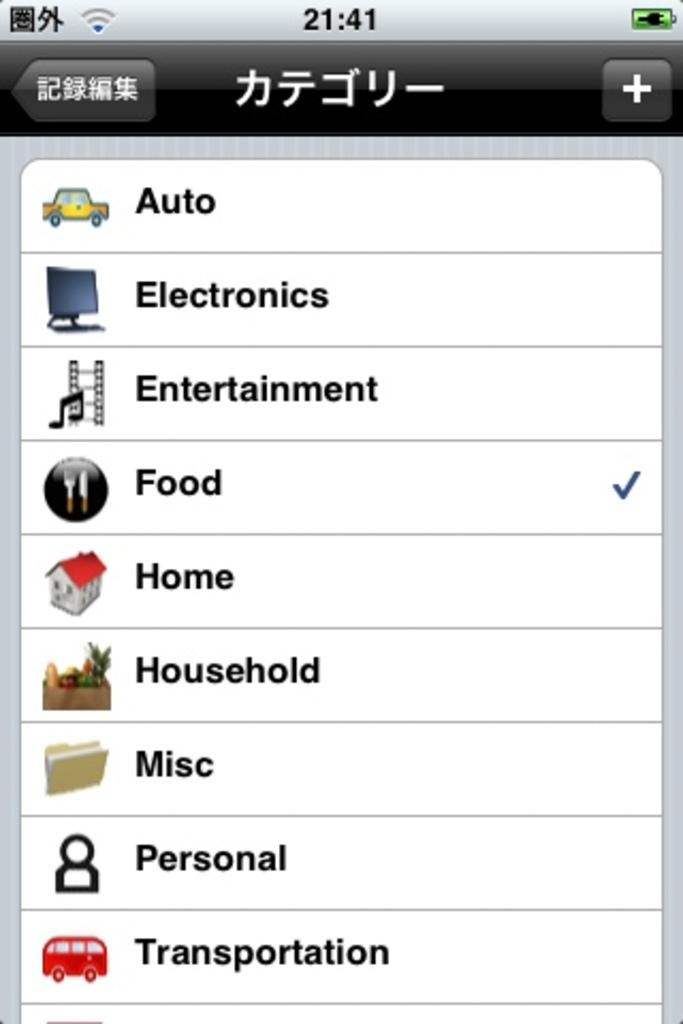<image>
Summarize the visual content of the image. A cellphone screen with Chinese writing at the top and the category food checked off. 